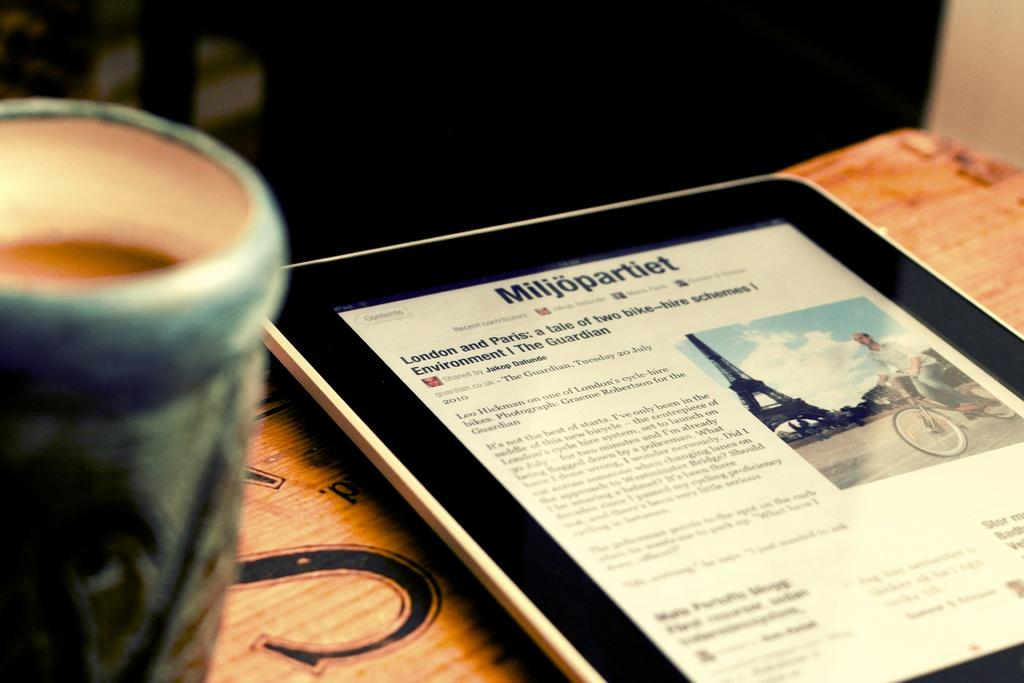<image>
Summarize the visual content of the image. A black tablet with a website called " Miljopartiet" showing on the screen. 